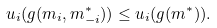Convert formula to latex. <formula><loc_0><loc_0><loc_500><loc_500>u _ { i } ( g ( m _ { i } , m _ { - i } ^ { * } ) ) \leq u _ { i } ( g ( m ^ { * } ) ) .</formula> 